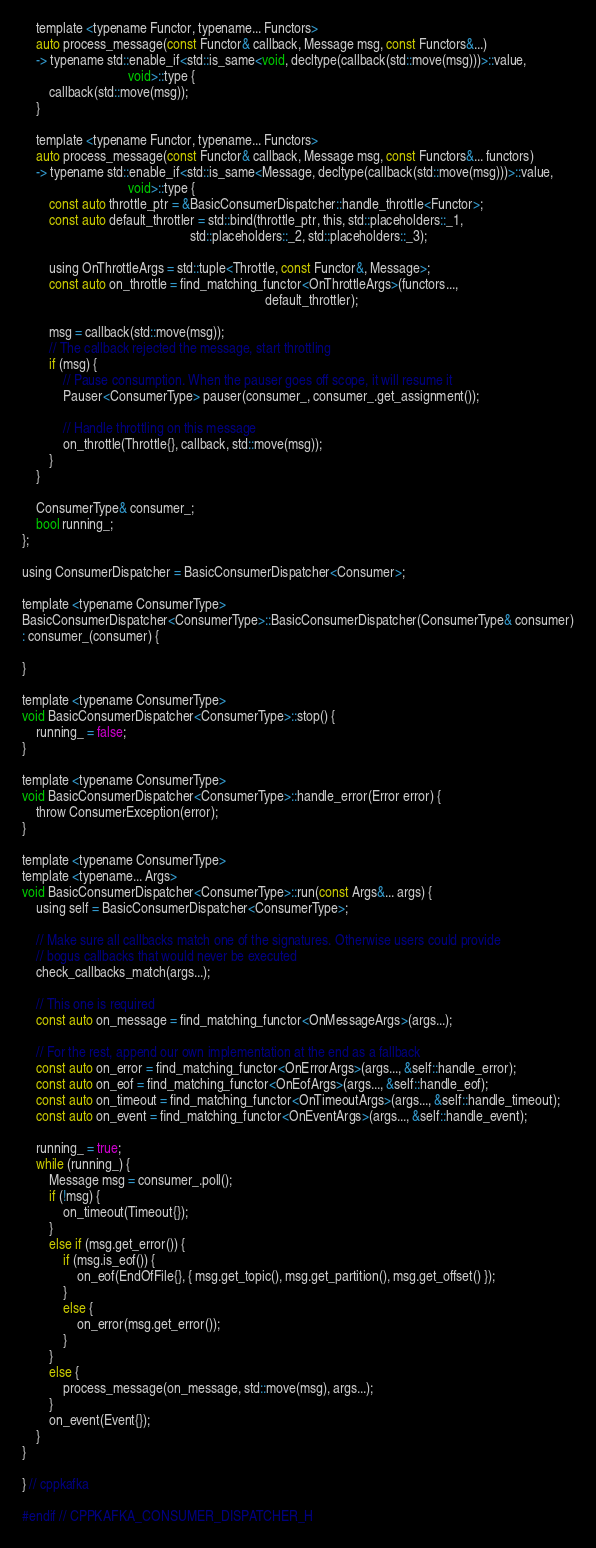<code> <loc_0><loc_0><loc_500><loc_500><_C_>    template <typename Functor, typename... Functors>
    auto process_message(const Functor& callback, Message msg, const Functors&...) 
    -> typename std::enable_if<std::is_same<void, decltype(callback(std::move(msg)))>::value,
                               void>::type {
        callback(std::move(msg));
    }

    template <typename Functor, typename... Functors>
    auto process_message(const Functor& callback, Message msg, const Functors&... functors)
    -> typename std::enable_if<std::is_same<Message, decltype(callback(std::move(msg)))>::value,
                               void>::type { 
        const auto throttle_ptr = &BasicConsumerDispatcher::handle_throttle<Functor>;
        const auto default_throttler = std::bind(throttle_ptr, this, std::placeholders::_1,
                                                 std::placeholders::_2, std::placeholders::_3);

        using OnThrottleArgs = std::tuple<Throttle, const Functor&, Message>;  
        const auto on_throttle = find_matching_functor<OnThrottleArgs>(functors...,
                                                                       default_throttler);
        
        msg = callback(std::move(msg));
        // The callback rejected the message, start throttling
        if (msg) {
            // Pause consumption. When the pauser goes off scope, it will resume it
            Pauser<ConsumerType> pauser(consumer_, consumer_.get_assignment());

            // Handle throttling on this message
            on_throttle(Throttle{}, callback, std::move(msg));
        }
    }

    ConsumerType& consumer_;
    bool running_;
};

using ConsumerDispatcher = BasicConsumerDispatcher<Consumer>;

template <typename ConsumerType>
BasicConsumerDispatcher<ConsumerType>::BasicConsumerDispatcher(ConsumerType& consumer)
: consumer_(consumer) {

}

template <typename ConsumerType>
void BasicConsumerDispatcher<ConsumerType>::stop() {
    running_ = false;
}

template <typename ConsumerType>
void BasicConsumerDispatcher<ConsumerType>::handle_error(Error error) {
    throw ConsumerException(error);
}

template <typename ConsumerType>
template <typename... Args>
void BasicConsumerDispatcher<ConsumerType>::run(const Args&... args) {
    using self = BasicConsumerDispatcher<ConsumerType>;
    
    // Make sure all callbacks match one of the signatures. Otherwise users could provide
    // bogus callbacks that would never be executed
    check_callbacks_match(args...);

    // This one is required
    const auto on_message = find_matching_functor<OnMessageArgs>(args...);

    // For the rest, append our own implementation at the end as a fallback
    const auto on_error = find_matching_functor<OnErrorArgs>(args..., &self::handle_error);
    const auto on_eof = find_matching_functor<OnEofArgs>(args..., &self::handle_eof);
    const auto on_timeout = find_matching_functor<OnTimeoutArgs>(args..., &self::handle_timeout);
    const auto on_event = find_matching_functor<OnEventArgs>(args..., &self::handle_event);

    running_ = true;
    while (running_) {
        Message msg = consumer_.poll();
        if (!msg) {
            on_timeout(Timeout{});
        }
        else if (msg.get_error()) {
            if (msg.is_eof()) {
                on_eof(EndOfFile{}, { msg.get_topic(), msg.get_partition(), msg.get_offset() });
            }
            else {
                on_error(msg.get_error());
            }
        }
        else {
            process_message(on_message, std::move(msg), args...);
        }
        on_event(Event{});
    }
}

} // cppkafka

#endif // CPPKAFKA_CONSUMER_DISPATCHER_H
</code> 